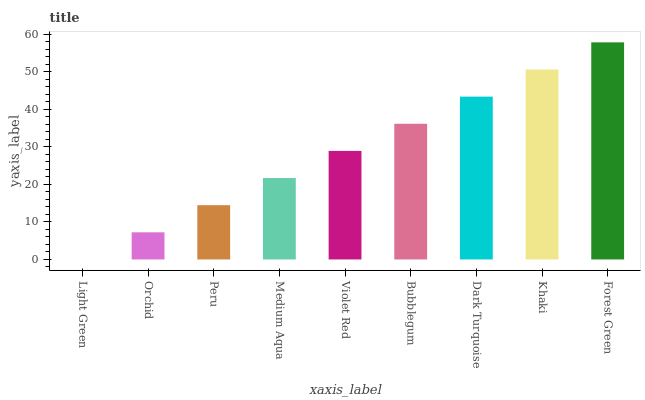Is Light Green the minimum?
Answer yes or no. Yes. Is Forest Green the maximum?
Answer yes or no. Yes. Is Orchid the minimum?
Answer yes or no. No. Is Orchid the maximum?
Answer yes or no. No. Is Orchid greater than Light Green?
Answer yes or no. Yes. Is Light Green less than Orchid?
Answer yes or no. Yes. Is Light Green greater than Orchid?
Answer yes or no. No. Is Orchid less than Light Green?
Answer yes or no. No. Is Violet Red the high median?
Answer yes or no. Yes. Is Violet Red the low median?
Answer yes or no. Yes. Is Forest Green the high median?
Answer yes or no. No. Is Bubblegum the low median?
Answer yes or no. No. 